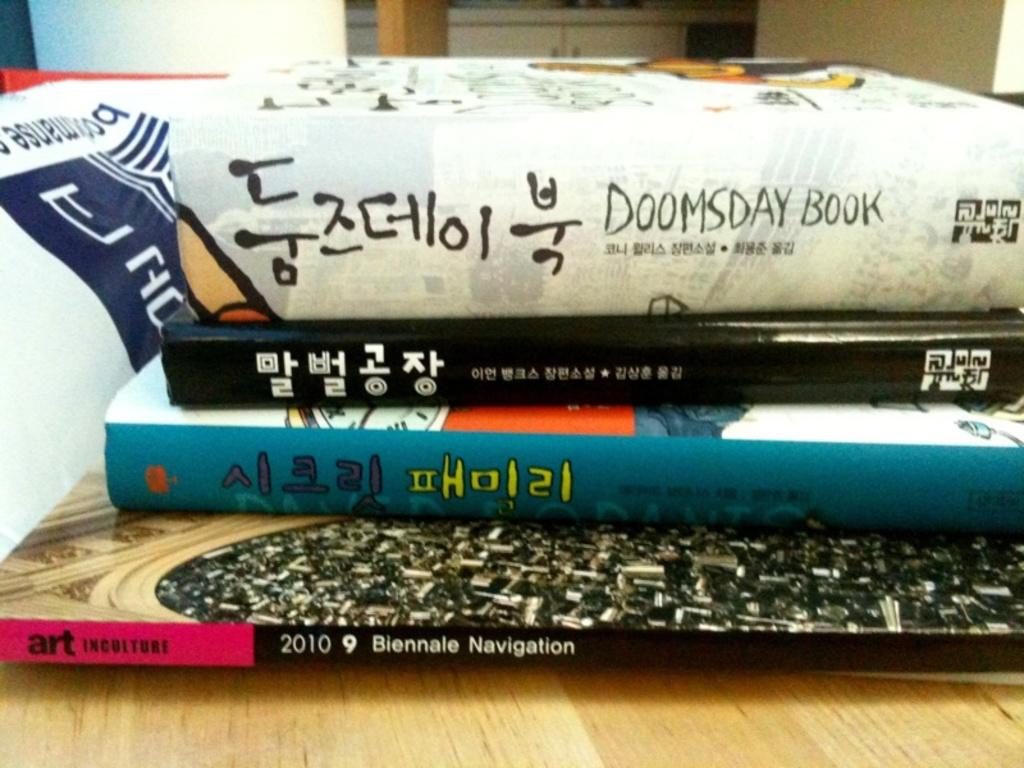What is the book on the bottom?
Offer a very short reply. Biennale navigation. What is the title of the book on the top?
Provide a succinct answer. Doomsday book. 